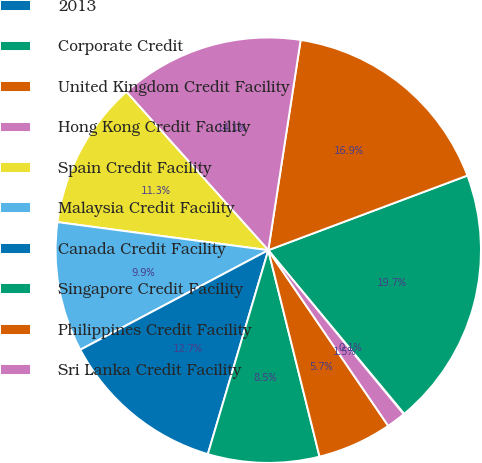Convert chart. <chart><loc_0><loc_0><loc_500><loc_500><pie_chart><fcel>2013<fcel>Corporate Credit<fcel>United Kingdom Credit Facility<fcel>Hong Kong Credit Facility<fcel>Spain Credit Facility<fcel>Malaysia Credit Facility<fcel>Canada Credit Facility<fcel>Singapore Credit Facility<fcel>Philippines Credit Facility<fcel>Sri Lanka Credit Facility<nl><fcel>0.05%<fcel>19.67%<fcel>16.86%<fcel>14.06%<fcel>11.26%<fcel>9.86%<fcel>12.66%<fcel>8.46%<fcel>5.66%<fcel>1.45%<nl></chart> 